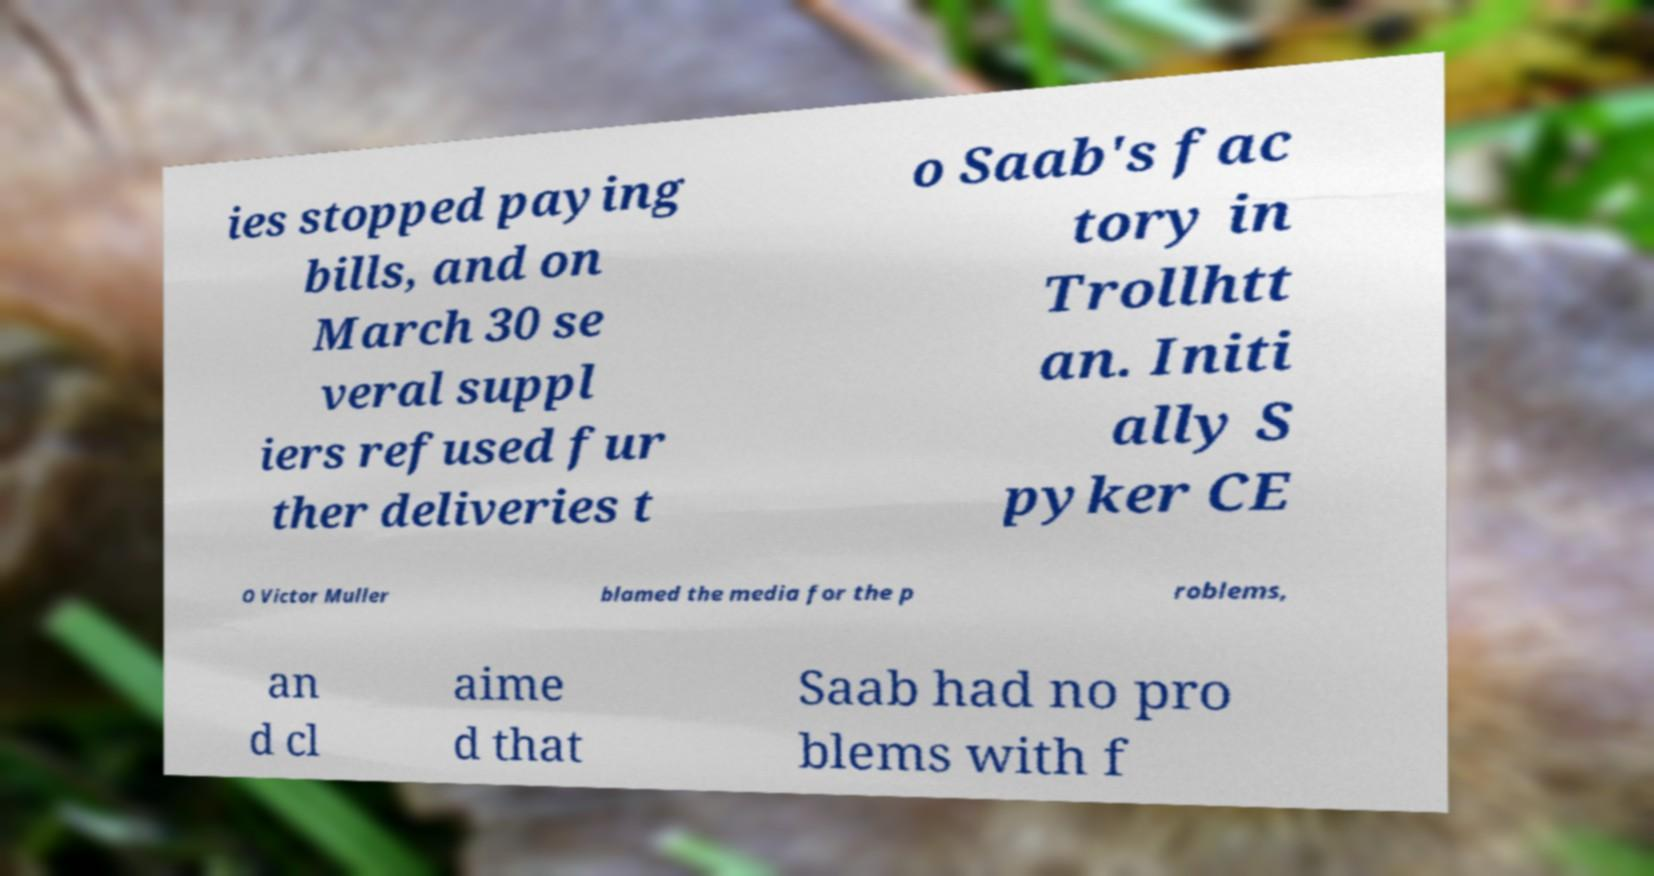Could you extract and type out the text from this image? ies stopped paying bills, and on March 30 se veral suppl iers refused fur ther deliveries t o Saab's fac tory in Trollhtt an. Initi ally S pyker CE O Victor Muller blamed the media for the p roblems, an d cl aime d that Saab had no pro blems with f 